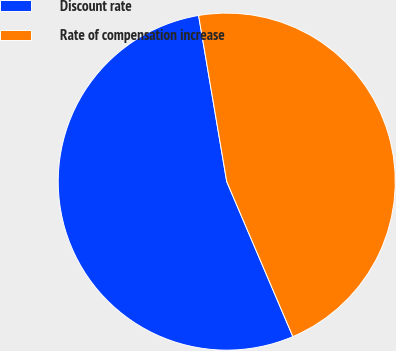Convert chart to OTSL. <chart><loc_0><loc_0><loc_500><loc_500><pie_chart><fcel>Discount rate<fcel>Rate of compensation increase<nl><fcel>53.75%<fcel>46.25%<nl></chart> 